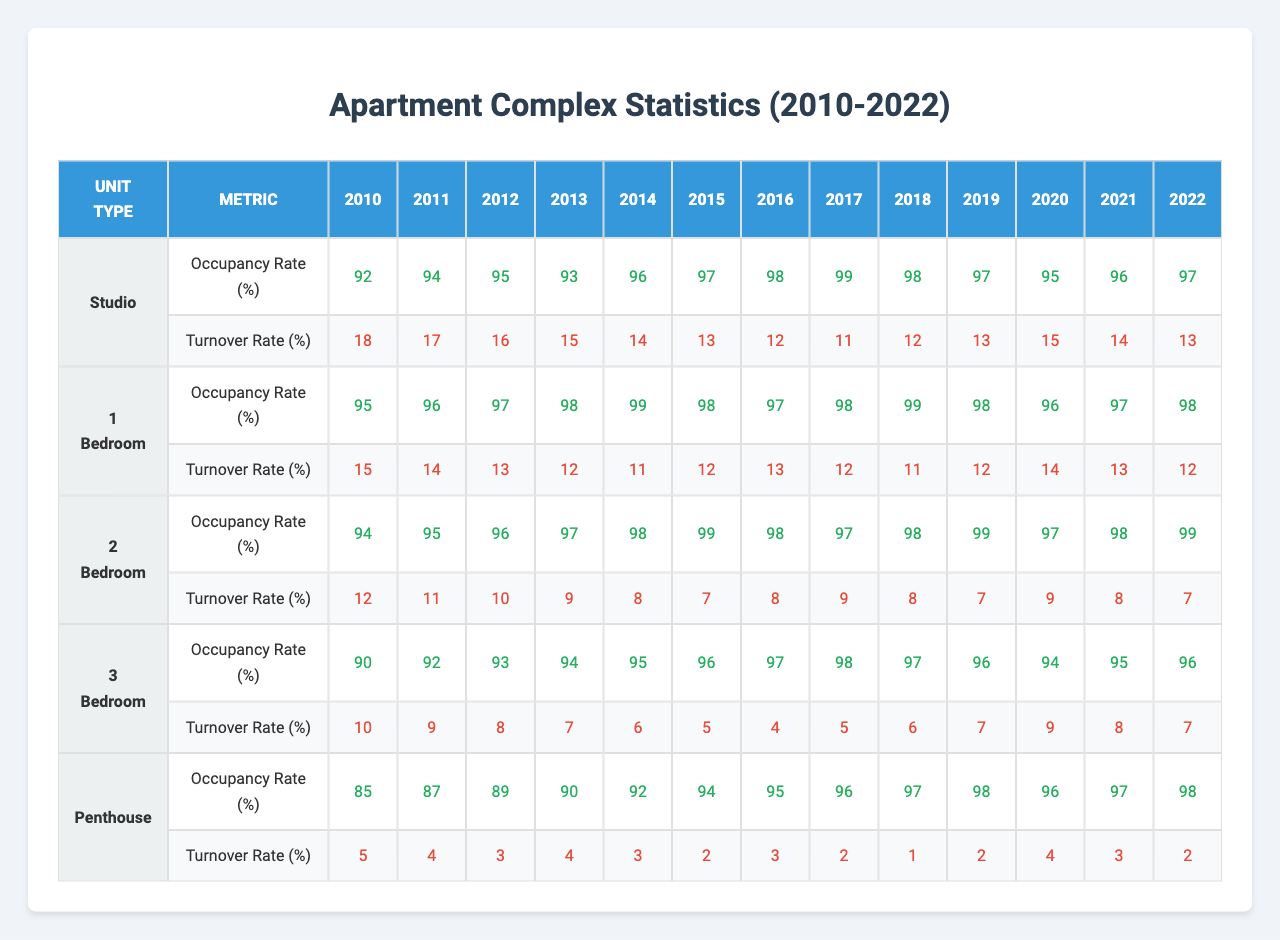What was the occupancy rate for 2 Bedroom units in 2015? According to the table, the occupancy rate for 2 Bedroom units in 2015 is the 6th value in the row for 2 Bedroom units, which is 99%.
Answer: 99% What is the turnover rate for the Penthouse units in 2020? The turnover rate for the Penthouse units in 2020 can be found in the row corresponding to Penthouse units, specifically the 11th value, which is 4%.
Answer: 4% Which unit type had the highest occupancy rate in 2018? To determine which unit type had the highest occupancy rate in 2018, we need to compare the occupancy rates for all unit types in that year. The rates are: Studio (98%), 1 Bedroom (99%), 2 Bedroom (98%), 3 Bedroom (97%), and Penthouse (97%). The highest rate is 99% for 1 Bedroom.
Answer: 1 Bedroom What is the average turnover rate for all unit types in 2022? To calculate the average turnover rate for 2022, we take the turnover rates for all unit types in that year, which are: Studio (13%), 1 Bedroom (12%), 2 Bedroom (7%), 3 Bedroom (7%), and Penthouse (2%). The sum of these rates is 41%. Dividing by the number of unit types (5) gives us an average rate of 8.2%.
Answer: 8.2% Which unit type had the lowest turnover rate in 2013? The table shows the turnover rates for all unit types in 2013: Studio (15%), 1 Bedroom (12%), 2 Bedroom (9%), 3 Bedroom (7%), and Penthouse (4%). The lowest rate is 4% for Penthouse units.
Answer: Penthouse Has the occupancy rate for Studio units ever dipped below 90%? By examining the occupancy rates for Studio units from 2010 to 2022, we can see the rates are 92%, 94%, 95%, 93%, 96%, 97%, 98%, 99%, 98%, 97%, 95%, 96%, and 97%. None of these values dip below 90%.
Answer: No What is the increase in occupancy rate from 2010 to 2022 for 3 Bedroom units? The occupancy rate for 3 Bedroom units in 2010 is 90%, and in 2022, it is 96%. The increase is calculated as 96% - 90% = 6%.
Answer: 6% In which year did the turnover rate for 1 Bedroom units see its lowest value? Observing the turnover rates for 1 Bedroom units from 2010 to 2022, the values are 15%, 14%, 13%, 12%, 11%, 12%, 13%, 12%, 11%, 12%, 14%, 13%, and 12%. The lowest value is 11%, found in 2014 and 2018.
Answer: 2014 and 2018 What was the occupancy rate trend for 2 Bedroom units from 2010 to 2022? Reviewing the occupancy rates for 2 Bedroom units: 94%, 95%, 96%, 97%, 98%, 99%, 98%, 97%, 98%, 99%, 97%, 98%, and 99%. The rates generally increased from 2010 to 2019, reaching a peak of 99%, before stabilizing between 97% and 99% in the last three years.
Answer: Generally increasing, stabilizing in the last three years 